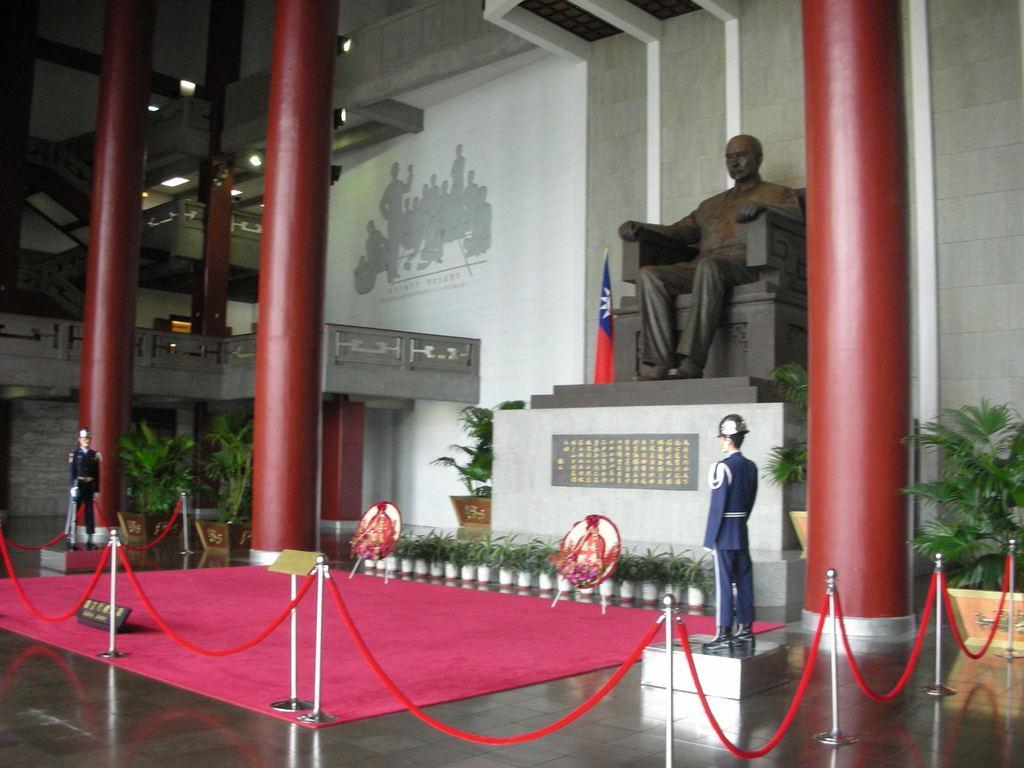In one or two sentences, can you explain what this image depicts? In this image we can see the inner view of a building and there is a statue of a person sitting on chair and there are two other statues which resembles soldiers and there is a board. We can see barricades around the statues and there are some potted plants. 